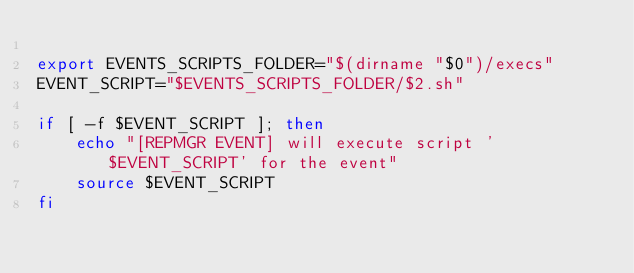Convert code to text. <code><loc_0><loc_0><loc_500><loc_500><_Bash_>
export EVENTS_SCRIPTS_FOLDER="$(dirname "$0")/execs"
EVENT_SCRIPT="$EVENTS_SCRIPTS_FOLDER/$2.sh"

if [ -f $EVENT_SCRIPT ]; then
    echo "[REPMGR EVENT] will execute script '$EVENT_SCRIPT' for the event"
    source $EVENT_SCRIPT
fi</code> 